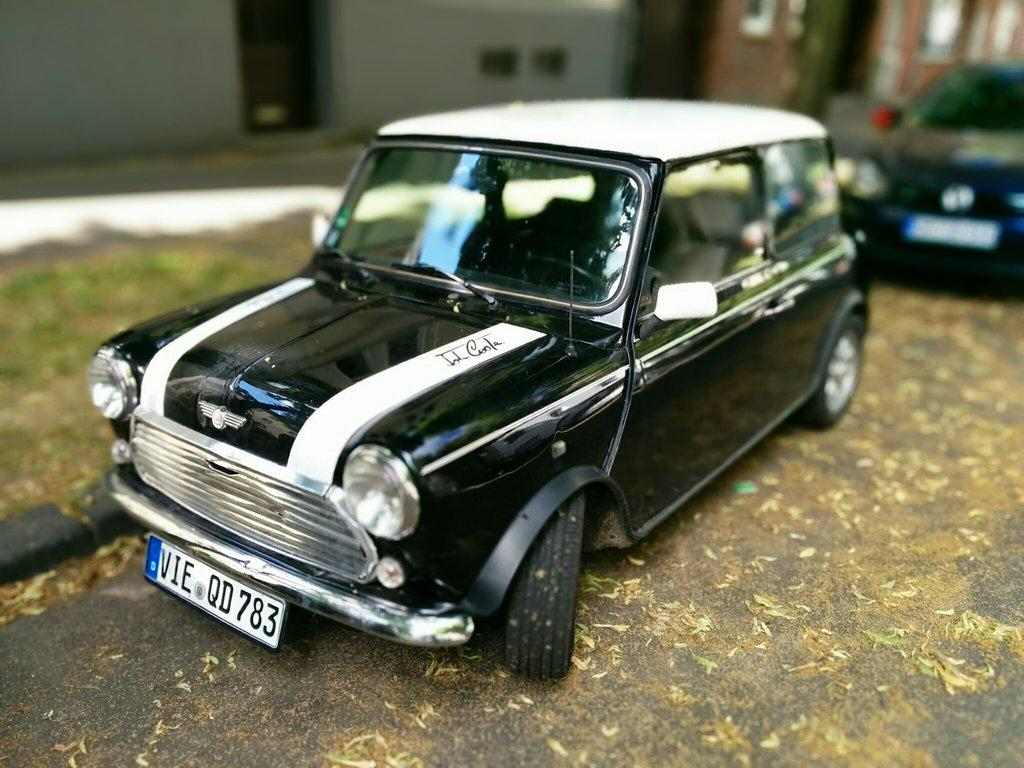What is the main subject of the image? The main subject of the image is a toy car. Can you describe the background of the toy car? The background of the toy car is blurred. What type of pen can be seen being used by the rat in the image? There is no pen or rat present in the image; it only features a toy car with a blurred background. 